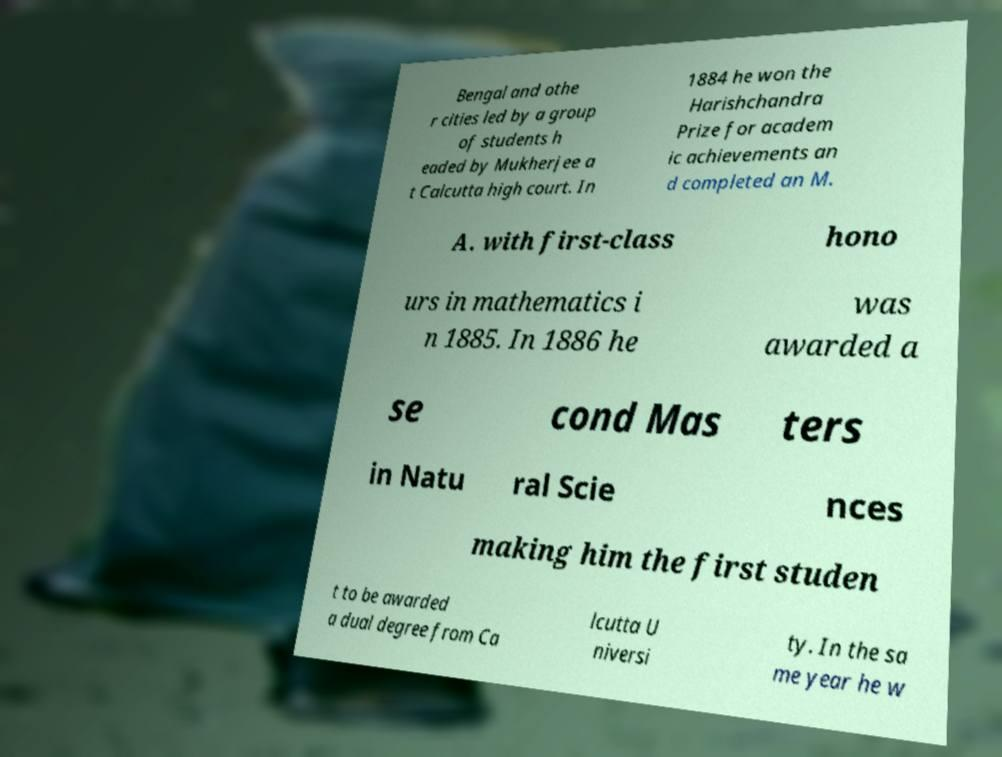Could you assist in decoding the text presented in this image and type it out clearly? Bengal and othe r cities led by a group of students h eaded by Mukherjee a t Calcutta high court. In 1884 he won the Harishchandra Prize for academ ic achievements an d completed an M. A. with first-class hono urs in mathematics i n 1885. In 1886 he was awarded a se cond Mas ters in Natu ral Scie nces making him the first studen t to be awarded a dual degree from Ca lcutta U niversi ty. In the sa me year he w 